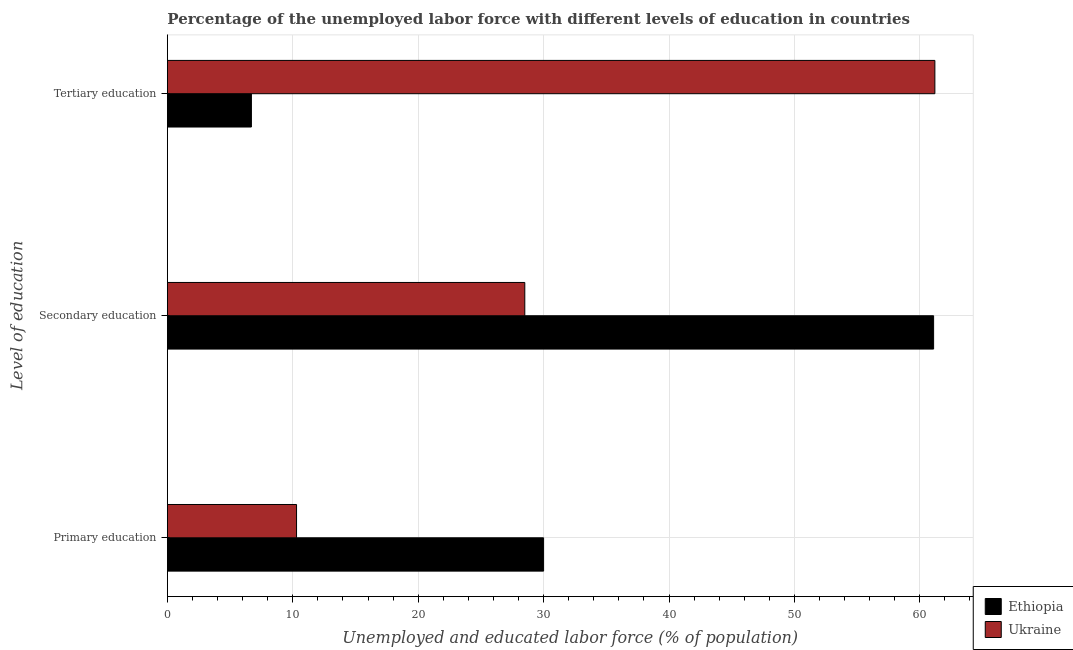Are the number of bars per tick equal to the number of legend labels?
Your answer should be compact. Yes. Are the number of bars on each tick of the Y-axis equal?
Make the answer very short. Yes. How many bars are there on the 2nd tick from the top?
Give a very brief answer. 2. How many bars are there on the 3rd tick from the bottom?
Your answer should be very brief. 2. What is the label of the 1st group of bars from the top?
Your response must be concise. Tertiary education. What is the percentage of labor force who received primary education in Ethiopia?
Give a very brief answer. 30. Across all countries, what is the maximum percentage of labor force who received secondary education?
Your answer should be very brief. 61.1. Across all countries, what is the minimum percentage of labor force who received tertiary education?
Provide a succinct answer. 6.7. In which country was the percentage of labor force who received primary education maximum?
Ensure brevity in your answer.  Ethiopia. In which country was the percentage of labor force who received secondary education minimum?
Make the answer very short. Ukraine. What is the total percentage of labor force who received secondary education in the graph?
Your response must be concise. 89.6. What is the difference between the percentage of labor force who received tertiary education in Ethiopia and that in Ukraine?
Keep it short and to the point. -54.5. What is the difference between the percentage of labor force who received tertiary education in Ukraine and the percentage of labor force who received primary education in Ethiopia?
Give a very brief answer. 31.2. What is the average percentage of labor force who received tertiary education per country?
Your answer should be very brief. 33.95. What is the difference between the percentage of labor force who received secondary education and percentage of labor force who received tertiary education in Ukraine?
Provide a short and direct response. -32.7. In how many countries, is the percentage of labor force who received tertiary education greater than 38 %?
Make the answer very short. 1. What is the ratio of the percentage of labor force who received primary education in Ethiopia to that in Ukraine?
Your answer should be compact. 2.91. Is the percentage of labor force who received secondary education in Ukraine less than that in Ethiopia?
Your answer should be very brief. Yes. Is the difference between the percentage of labor force who received primary education in Ethiopia and Ukraine greater than the difference between the percentage of labor force who received tertiary education in Ethiopia and Ukraine?
Your answer should be compact. Yes. What is the difference between the highest and the second highest percentage of labor force who received primary education?
Ensure brevity in your answer.  19.7. What is the difference between the highest and the lowest percentage of labor force who received primary education?
Provide a short and direct response. 19.7. In how many countries, is the percentage of labor force who received primary education greater than the average percentage of labor force who received primary education taken over all countries?
Make the answer very short. 1. Is the sum of the percentage of labor force who received tertiary education in Ukraine and Ethiopia greater than the maximum percentage of labor force who received secondary education across all countries?
Give a very brief answer. Yes. What does the 1st bar from the top in Tertiary education represents?
Provide a succinct answer. Ukraine. What does the 2nd bar from the bottom in Primary education represents?
Ensure brevity in your answer.  Ukraine. Is it the case that in every country, the sum of the percentage of labor force who received primary education and percentage of labor force who received secondary education is greater than the percentage of labor force who received tertiary education?
Your answer should be very brief. No. How many bars are there?
Your answer should be very brief. 6. How many countries are there in the graph?
Your response must be concise. 2. What is the difference between two consecutive major ticks on the X-axis?
Keep it short and to the point. 10. Does the graph contain any zero values?
Keep it short and to the point. No. How many legend labels are there?
Keep it short and to the point. 2. How are the legend labels stacked?
Your response must be concise. Vertical. What is the title of the graph?
Your response must be concise. Percentage of the unemployed labor force with different levels of education in countries. What is the label or title of the X-axis?
Your response must be concise. Unemployed and educated labor force (% of population). What is the label or title of the Y-axis?
Your answer should be compact. Level of education. What is the Unemployed and educated labor force (% of population) in Ethiopia in Primary education?
Your answer should be compact. 30. What is the Unemployed and educated labor force (% of population) of Ukraine in Primary education?
Your answer should be compact. 10.3. What is the Unemployed and educated labor force (% of population) of Ethiopia in Secondary education?
Offer a terse response. 61.1. What is the Unemployed and educated labor force (% of population) of Ukraine in Secondary education?
Keep it short and to the point. 28.5. What is the Unemployed and educated labor force (% of population) in Ethiopia in Tertiary education?
Your answer should be very brief. 6.7. What is the Unemployed and educated labor force (% of population) of Ukraine in Tertiary education?
Your response must be concise. 61.2. Across all Level of education, what is the maximum Unemployed and educated labor force (% of population) in Ethiopia?
Your answer should be compact. 61.1. Across all Level of education, what is the maximum Unemployed and educated labor force (% of population) in Ukraine?
Make the answer very short. 61.2. Across all Level of education, what is the minimum Unemployed and educated labor force (% of population) in Ethiopia?
Provide a succinct answer. 6.7. Across all Level of education, what is the minimum Unemployed and educated labor force (% of population) of Ukraine?
Offer a very short reply. 10.3. What is the total Unemployed and educated labor force (% of population) in Ethiopia in the graph?
Give a very brief answer. 97.8. What is the difference between the Unemployed and educated labor force (% of population) of Ethiopia in Primary education and that in Secondary education?
Give a very brief answer. -31.1. What is the difference between the Unemployed and educated labor force (% of population) in Ukraine in Primary education and that in Secondary education?
Your response must be concise. -18.2. What is the difference between the Unemployed and educated labor force (% of population) in Ethiopia in Primary education and that in Tertiary education?
Give a very brief answer. 23.3. What is the difference between the Unemployed and educated labor force (% of population) of Ukraine in Primary education and that in Tertiary education?
Give a very brief answer. -50.9. What is the difference between the Unemployed and educated labor force (% of population) of Ethiopia in Secondary education and that in Tertiary education?
Your response must be concise. 54.4. What is the difference between the Unemployed and educated labor force (% of population) in Ukraine in Secondary education and that in Tertiary education?
Your response must be concise. -32.7. What is the difference between the Unemployed and educated labor force (% of population) in Ethiopia in Primary education and the Unemployed and educated labor force (% of population) in Ukraine in Secondary education?
Provide a short and direct response. 1.5. What is the difference between the Unemployed and educated labor force (% of population) of Ethiopia in Primary education and the Unemployed and educated labor force (% of population) of Ukraine in Tertiary education?
Ensure brevity in your answer.  -31.2. What is the average Unemployed and educated labor force (% of population) in Ethiopia per Level of education?
Provide a succinct answer. 32.6. What is the average Unemployed and educated labor force (% of population) of Ukraine per Level of education?
Offer a terse response. 33.33. What is the difference between the Unemployed and educated labor force (% of population) in Ethiopia and Unemployed and educated labor force (% of population) in Ukraine in Secondary education?
Provide a short and direct response. 32.6. What is the difference between the Unemployed and educated labor force (% of population) in Ethiopia and Unemployed and educated labor force (% of population) in Ukraine in Tertiary education?
Your response must be concise. -54.5. What is the ratio of the Unemployed and educated labor force (% of population) of Ethiopia in Primary education to that in Secondary education?
Provide a short and direct response. 0.49. What is the ratio of the Unemployed and educated labor force (% of population) of Ukraine in Primary education to that in Secondary education?
Ensure brevity in your answer.  0.36. What is the ratio of the Unemployed and educated labor force (% of population) of Ethiopia in Primary education to that in Tertiary education?
Provide a succinct answer. 4.48. What is the ratio of the Unemployed and educated labor force (% of population) in Ukraine in Primary education to that in Tertiary education?
Provide a short and direct response. 0.17. What is the ratio of the Unemployed and educated labor force (% of population) in Ethiopia in Secondary education to that in Tertiary education?
Give a very brief answer. 9.12. What is the ratio of the Unemployed and educated labor force (% of population) in Ukraine in Secondary education to that in Tertiary education?
Give a very brief answer. 0.47. What is the difference between the highest and the second highest Unemployed and educated labor force (% of population) in Ethiopia?
Offer a very short reply. 31.1. What is the difference between the highest and the second highest Unemployed and educated labor force (% of population) in Ukraine?
Ensure brevity in your answer.  32.7. What is the difference between the highest and the lowest Unemployed and educated labor force (% of population) of Ethiopia?
Offer a terse response. 54.4. What is the difference between the highest and the lowest Unemployed and educated labor force (% of population) in Ukraine?
Ensure brevity in your answer.  50.9. 